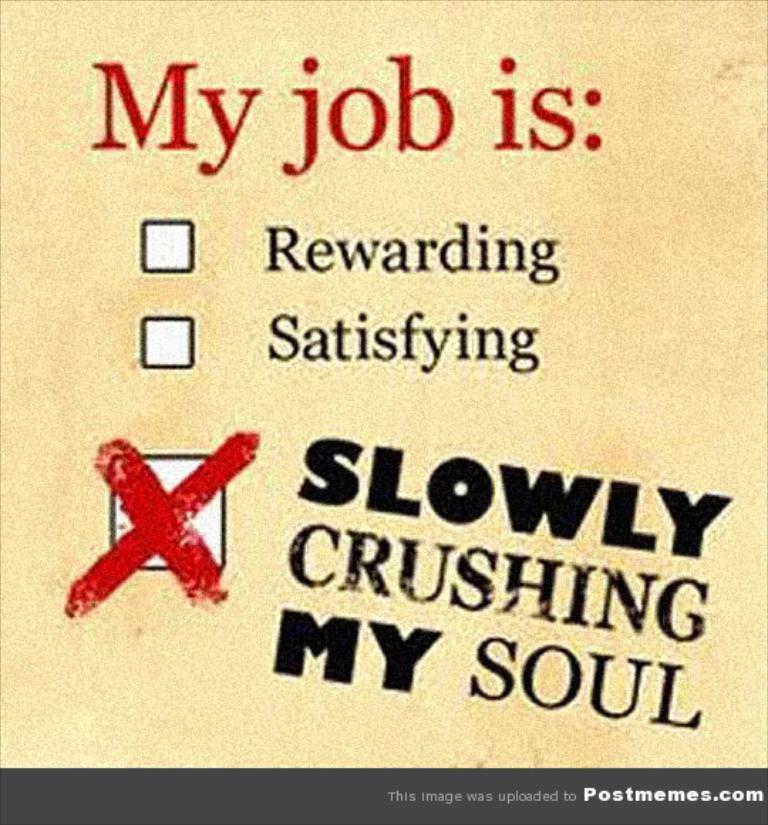Provide a one-sentence caption for the provided image. A postmemes.com sign that asks you to answer "My job is.". 